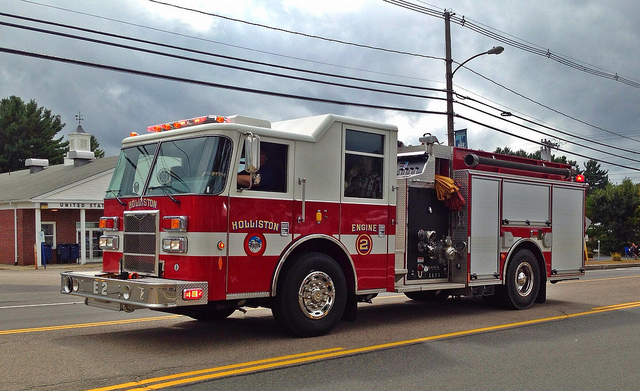Please transcribe the text information in this image. HOLLISTON ENGINE 2 E2 